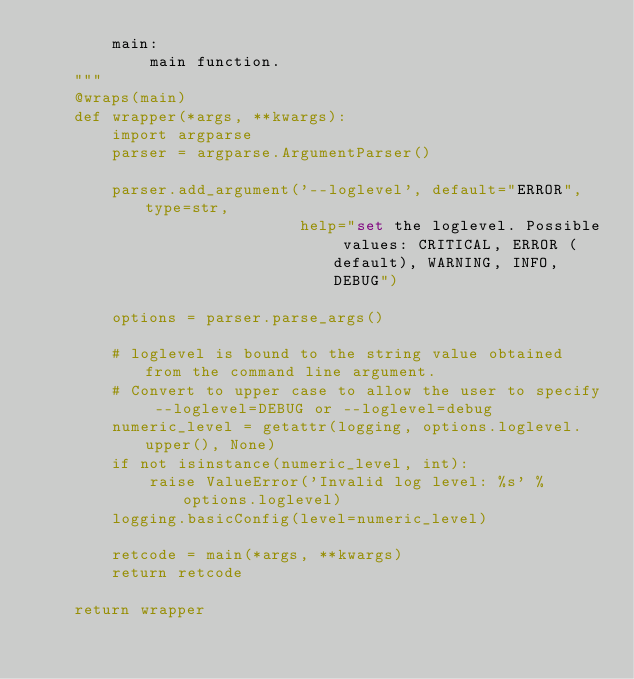Convert code to text. <code><loc_0><loc_0><loc_500><loc_500><_Python_>        main:
            main function.
    """
    @wraps(main)
    def wrapper(*args, **kwargs):
        import argparse
        parser = argparse.ArgumentParser()

        parser.add_argument('--loglevel', default="ERROR", type=str,
                            help="set the loglevel. Possible values: CRITICAL, ERROR (default), WARNING, INFO, DEBUG")

        options = parser.parse_args()

        # loglevel is bound to the string value obtained from the command line argument.
        # Convert to upper case to allow the user to specify --loglevel=DEBUG or --loglevel=debug
        numeric_level = getattr(logging, options.loglevel.upper(), None)
        if not isinstance(numeric_level, int):
            raise ValueError('Invalid log level: %s' % options.loglevel)
        logging.basicConfig(level=numeric_level)

        retcode = main(*args, **kwargs)
        return retcode

    return wrapper



</code> 